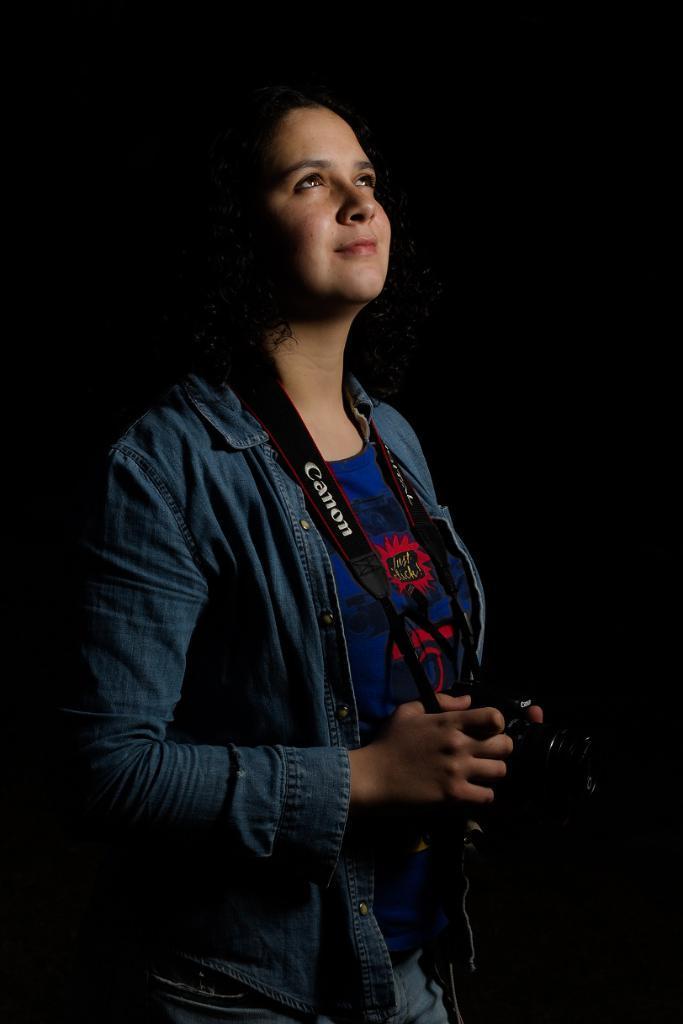Please provide a concise description of this image. In this image we can see a lady wearing blue jacket is holding a camera in her hands. 